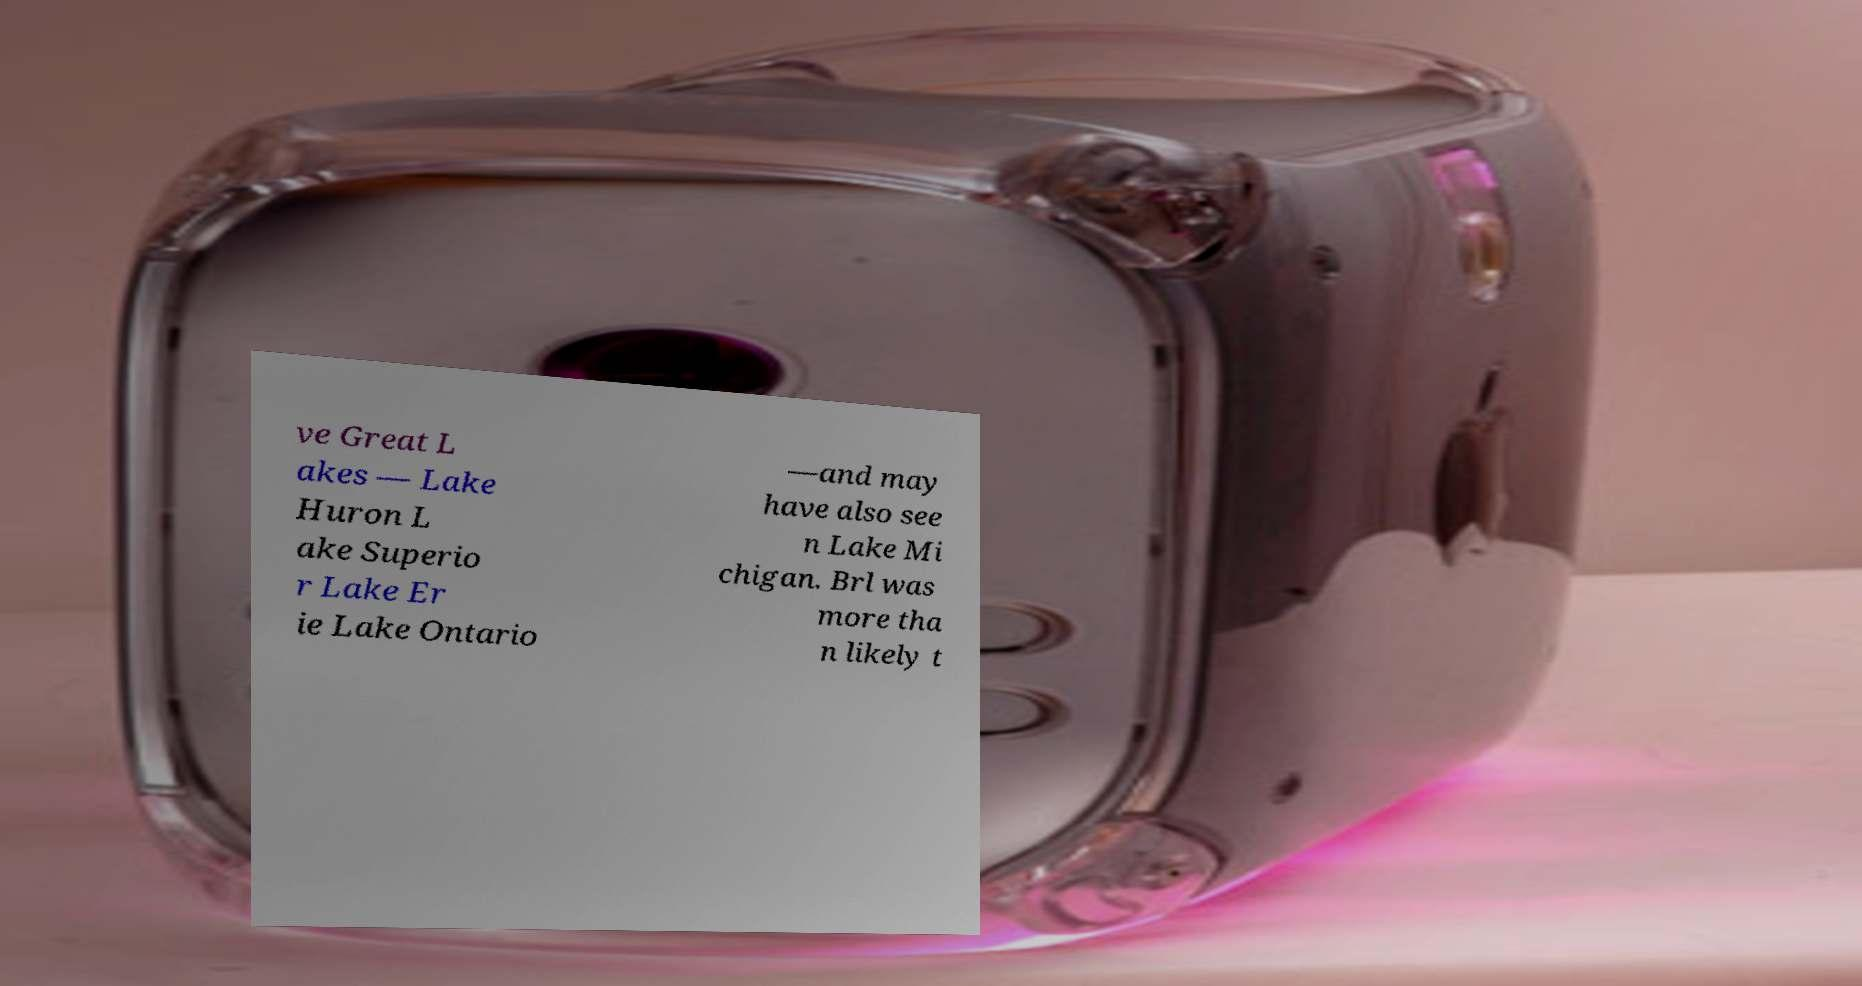Please identify and transcribe the text found in this image. ve Great L akes — Lake Huron L ake Superio r Lake Er ie Lake Ontario —and may have also see n Lake Mi chigan. Brl was more tha n likely t 